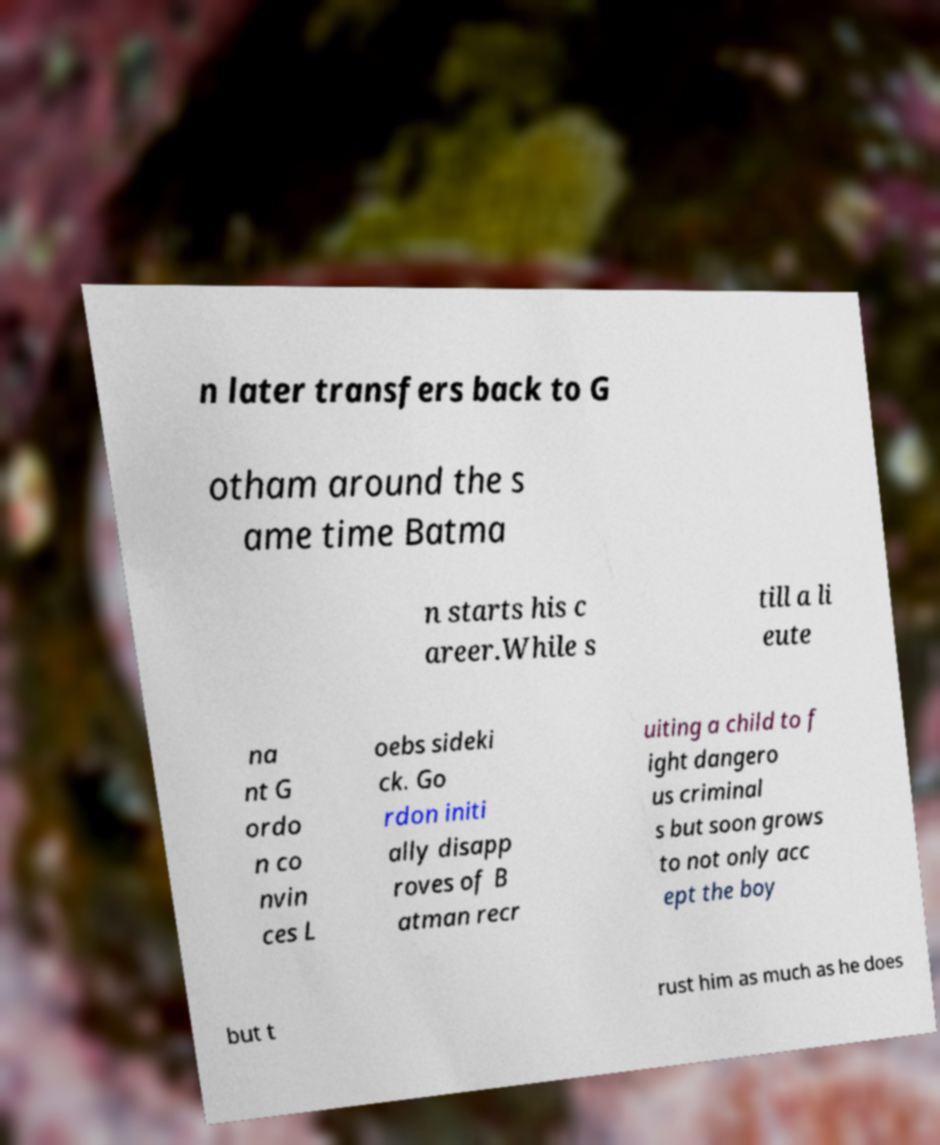Can you accurately transcribe the text from the provided image for me? n later transfers back to G otham around the s ame time Batma n starts his c areer.While s till a li eute na nt G ordo n co nvin ces L oebs sideki ck. Go rdon initi ally disapp roves of B atman recr uiting a child to f ight dangero us criminal s but soon grows to not only acc ept the boy but t rust him as much as he does 